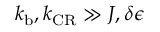<formula> <loc_0><loc_0><loc_500><loc_500>k _ { b } , k _ { C R } \gg J , \delta \epsilon</formula> 